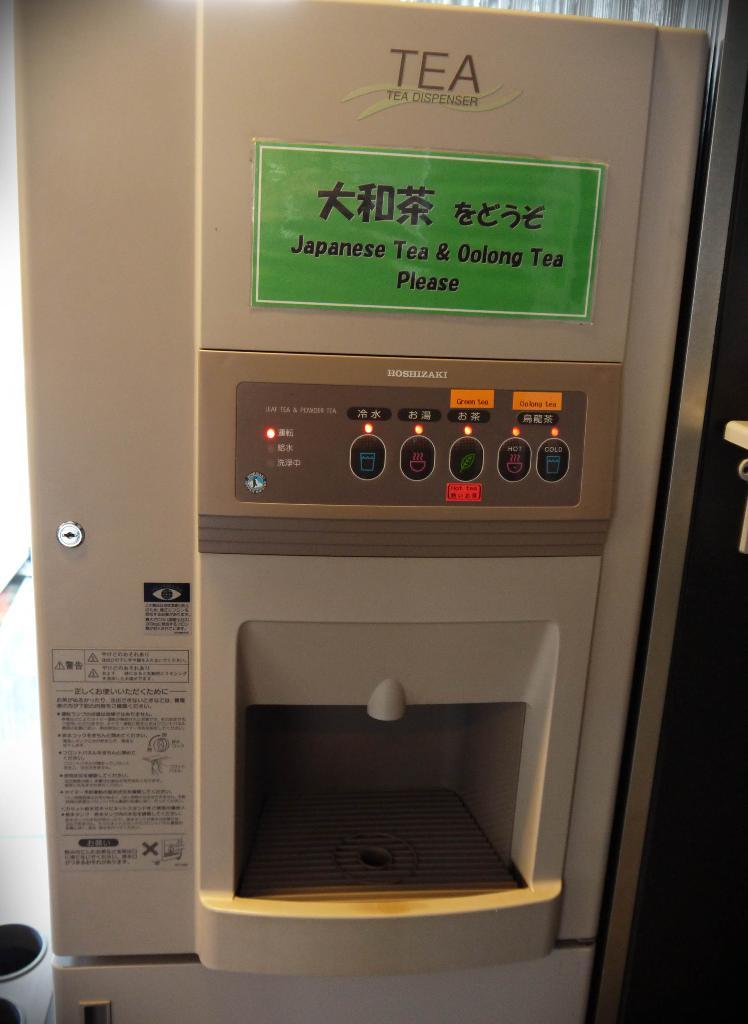<image>
Describe the image concisely. a vending machine selling Japanese tea and both Japanese and English words. 